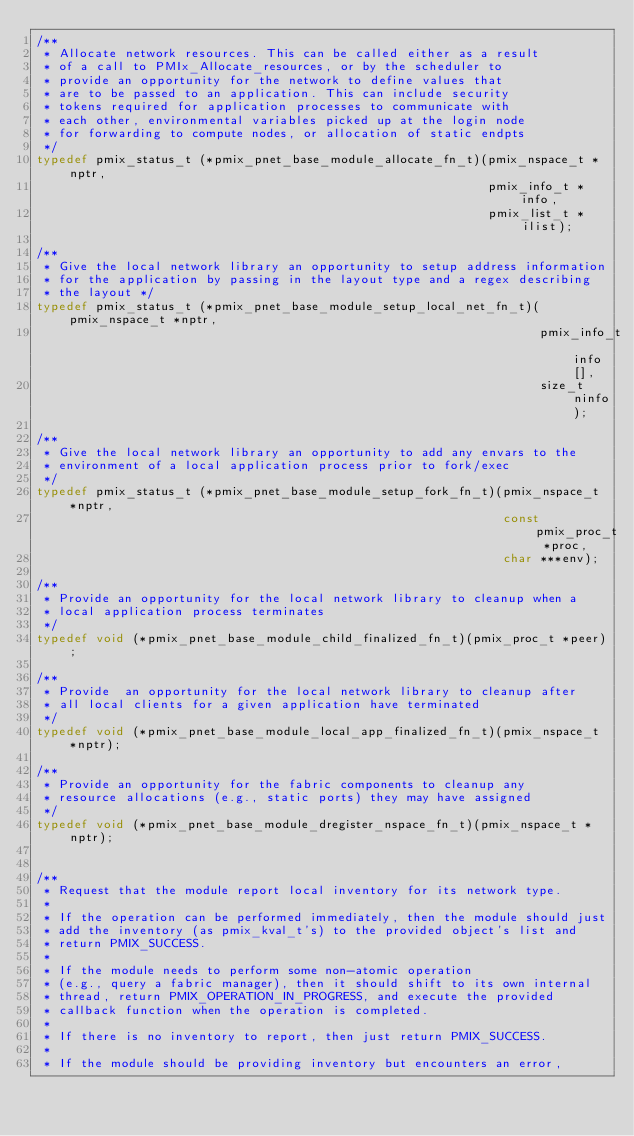Convert code to text. <code><loc_0><loc_0><loc_500><loc_500><_C_>/**
 * Allocate network resources. This can be called either as a result
 * of a call to PMIx_Allocate_resources, or by the scheduler to
 * provide an opportunity for the network to define values that
 * are to be passed to an application. This can include security
 * tokens required for application processes to communicate with
 * each other, environmental variables picked up at the login node
 * for forwarding to compute nodes, or allocation of static endpts
 */
typedef pmix_status_t (*pmix_pnet_base_module_allocate_fn_t)(pmix_nspace_t *nptr,
                                                             pmix_info_t *info,
                                                             pmix_list_t *ilist);

/**
 * Give the local network library an opportunity to setup address information
 * for the application by passing in the layout type and a regex describing
 * the layout */
typedef pmix_status_t (*pmix_pnet_base_module_setup_local_net_fn_t)(pmix_nspace_t *nptr,
                                                                    pmix_info_t info[],
                                                                    size_t ninfo);

/**
 * Give the local network library an opportunity to add any envars to the
 * environment of a local application process prior to fork/exec
 */
typedef pmix_status_t (*pmix_pnet_base_module_setup_fork_fn_t)(pmix_nspace_t *nptr,
                                                               const pmix_proc_t *proc,
                                                               char ***env);

/**
 * Provide an opportunity for the local network library to cleanup when a
 * local application process terminates
 */
typedef void (*pmix_pnet_base_module_child_finalized_fn_t)(pmix_proc_t *peer);

/**
 * Provide  an opportunity for the local network library to cleanup after
 * all local clients for a given application have terminated
 */
typedef void (*pmix_pnet_base_module_local_app_finalized_fn_t)(pmix_nspace_t *nptr);

/**
 * Provide an opportunity for the fabric components to cleanup any
 * resource allocations (e.g., static ports) they may have assigned
 */
typedef void (*pmix_pnet_base_module_dregister_nspace_fn_t)(pmix_nspace_t *nptr);


/**
 * Request that the module report local inventory for its network type.
 *
 * If the operation can be performed immediately, then the module should just
 * add the inventory (as pmix_kval_t's) to the provided object's list and
 * return PMIX_SUCCESS.
 *
 * If the module needs to perform some non-atomic operation
 * (e.g., query a fabric manager), then it should shift to its own internal
 * thread, return PMIX_OPERATION_IN_PROGRESS, and execute the provided
 * callback function when the operation is completed.
 *
 * If there is no inventory to report, then just return PMIX_SUCCESS.
 *
 * If the module should be providing inventory but encounters an error,</code> 